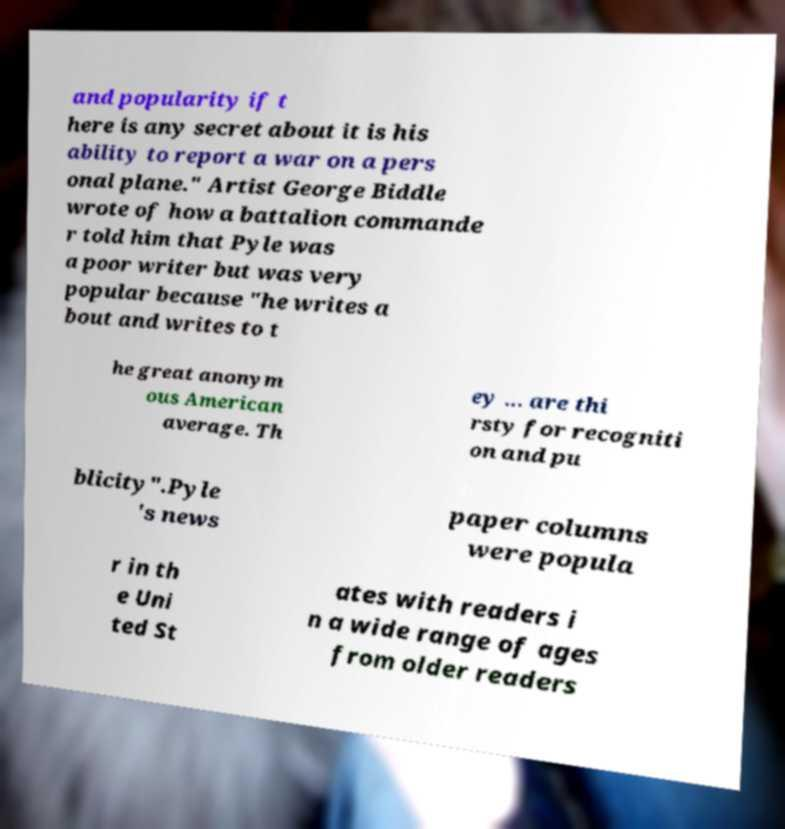Please identify and transcribe the text found in this image. and popularity if t here is any secret about it is his ability to report a war on a pers onal plane." Artist George Biddle wrote of how a battalion commande r told him that Pyle was a poor writer but was very popular because "he writes a bout and writes to t he great anonym ous American average. Th ey ... are thi rsty for recogniti on and pu blicity".Pyle 's news paper columns were popula r in th e Uni ted St ates with readers i n a wide range of ages from older readers 